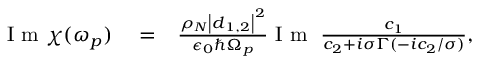<formula> <loc_0><loc_0><loc_500><loc_500>\begin{array} { r l r } { I m \chi ( \omega _ { p } ) } & = } & { \frac { \rho _ { N } \left | \boldsymbol d _ { 1 , 2 } \right | ^ { 2 } } { \epsilon _ { 0 } \hbar { \Omega } _ { p } } I m \, \frac { c _ { 1 } } { c _ { 2 } + i \sigma \Gamma ( - i c _ { 2 } / \sigma ) } , } \end{array}</formula> 